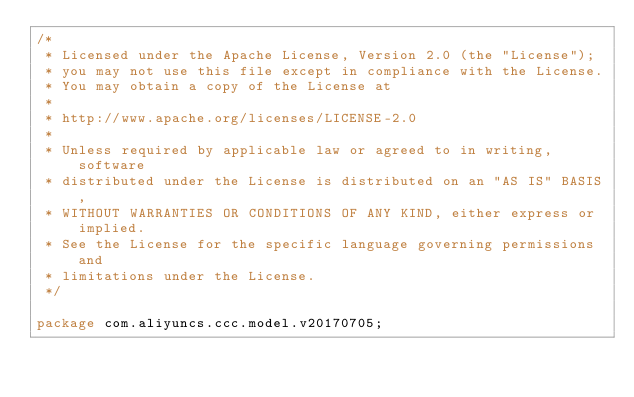Convert code to text. <code><loc_0><loc_0><loc_500><loc_500><_Java_>/*
 * Licensed under the Apache License, Version 2.0 (the "License");
 * you may not use this file except in compliance with the License.
 * You may obtain a copy of the License at
 *
 * http://www.apache.org/licenses/LICENSE-2.0
 *
 * Unless required by applicable law or agreed to in writing, software
 * distributed under the License is distributed on an "AS IS" BASIS,
 * WITHOUT WARRANTIES OR CONDITIONS OF ANY KIND, either express or implied.
 * See the License for the specific language governing permissions and
 * limitations under the License.
 */

package com.aliyuncs.ccc.model.v20170705;
</code> 